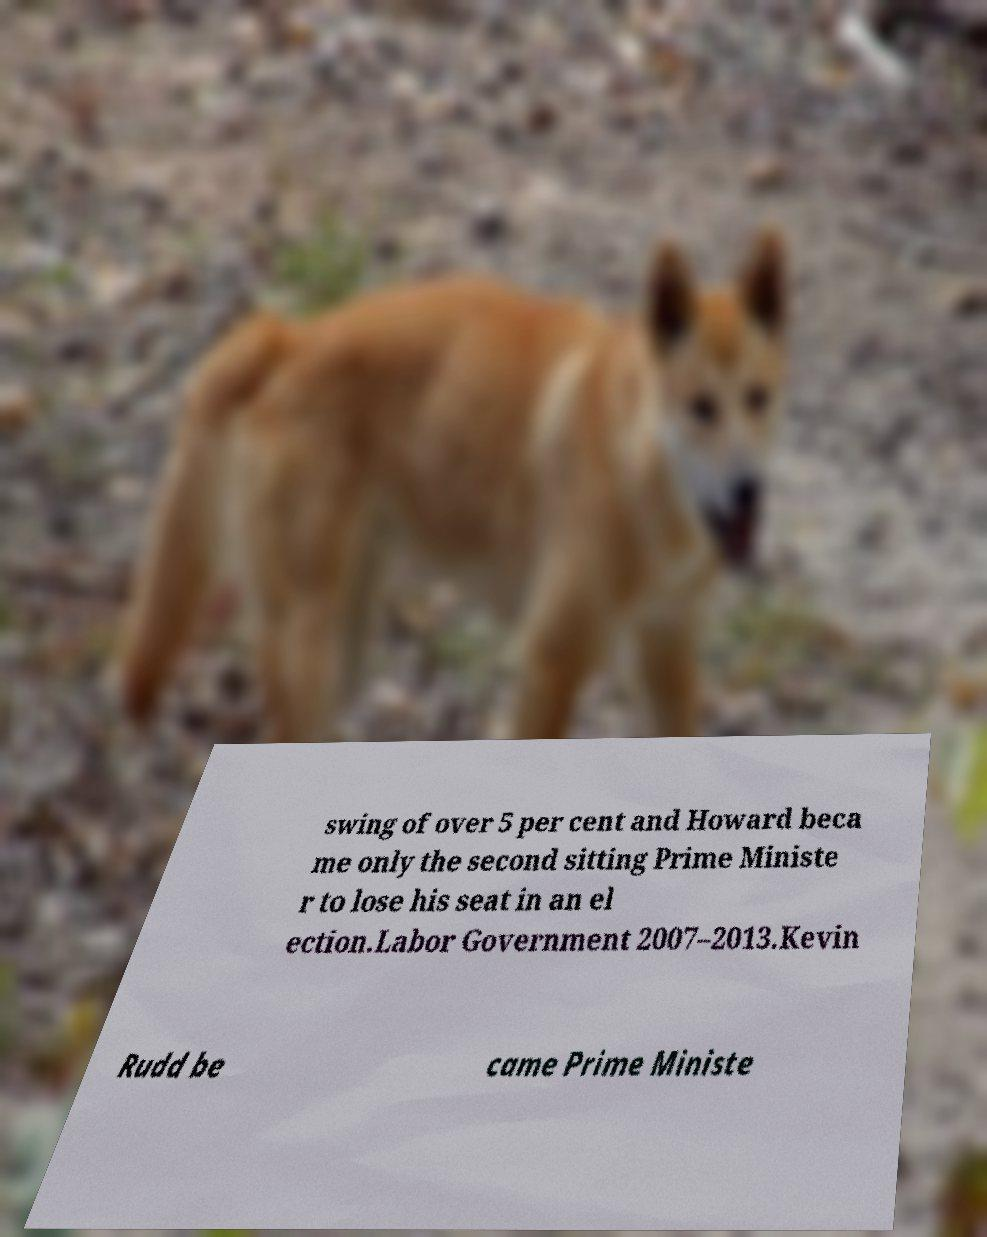I need the written content from this picture converted into text. Can you do that? swing of over 5 per cent and Howard beca me only the second sitting Prime Ministe r to lose his seat in an el ection.Labor Government 2007–2013.Kevin Rudd be came Prime Ministe 